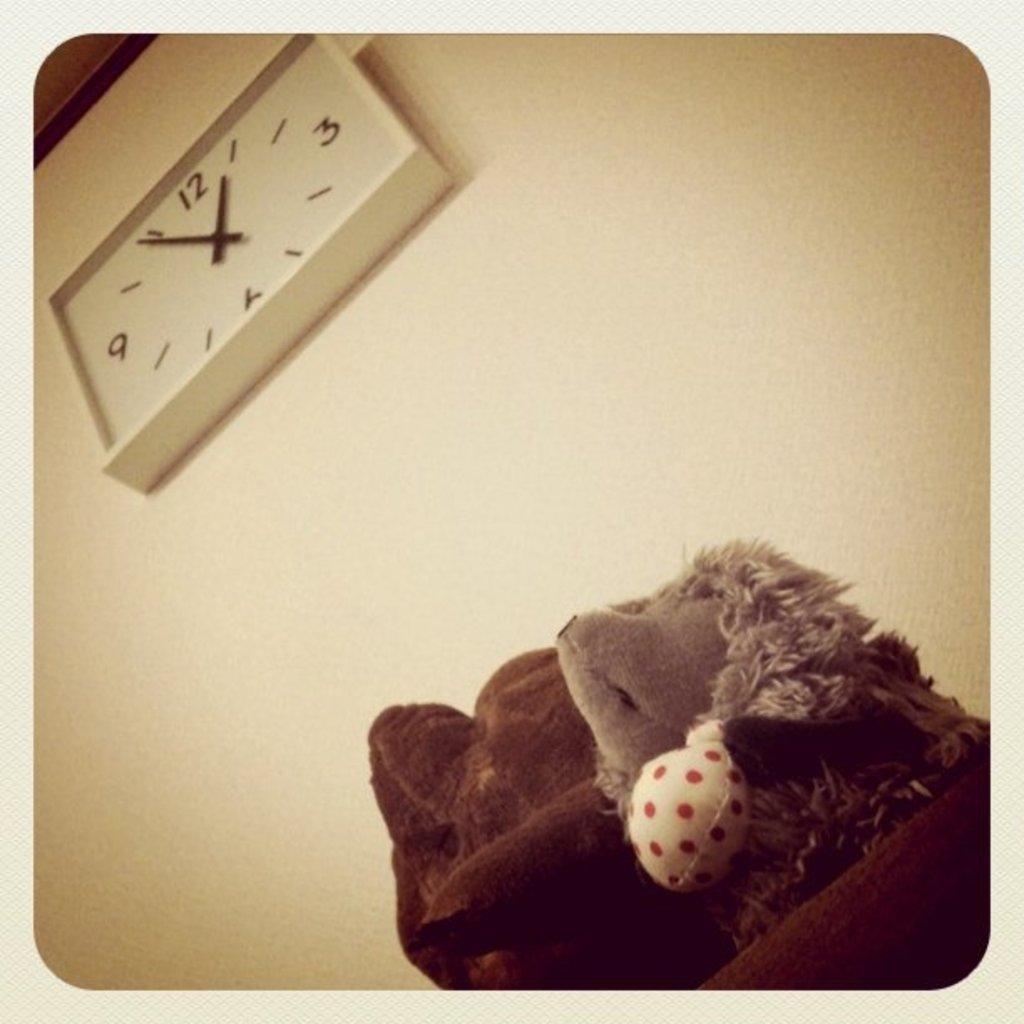Please provide a concise description of this image. In this picture there is a toy on the table. In the top left there is a wall clock on the wall. 